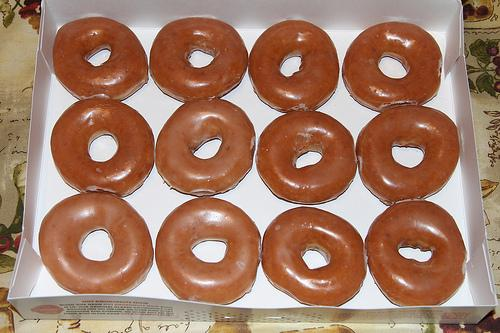How many doughnuts are in rows and covering approximately two-thirds of the box? There are eight doughnuts in two rows covering around two-thirds of the box. Are all the doughnuts in the box having the same glaze color? Yes, all the doughnuts in the box have the same white glaze color. Count the total number of doughnuts with a darker color in the image. There is one darker doughnut in the image. What is the total number of fruit and vegetable prints visible on the tablecloth? There are at least two different fruit and vegetable patterns on the tablecloth. What material is the box in the image made of? The box is made of cardboard. Describe any text or printing present on the donut box. There is writing on the side of the box, but its content is not specified in the image description. Evaluate the donut quality solely based on the visible appearance. The donuts appear to be of high quality, featuring smooth glaze and consistent coloring. Explain the visual sentiment portrayed in the image. The image conveys satisfaction and sweetness with a box of glazed doughnuts placed on a patterned tablecloth. Identify the primary object in the image and how many of it are present. There are 12 plain glazed doughnuts in the image. Describe the tablecloth in the image. The tablecloth has a pattern that includes vegetable prints and leaves. What is the main sentiment evoked by the image? Temptation or indulgence. Identify any discrepancies or abnormalities in the doughnuts in the last row. One doughnut is darker and another center is misshapen. Count the total number of glazed doughnuts in the image. 12 glazed doughnuts. Read the writing on the side of the box. Not available, the text is unspecified in the image information. Describe the attributes of the tablecloth. The tablecloth is patterned with a leaf or vegetable print. Is there any fruit on the table cloth? No, the pattern includes leaves or vegetables but not fruit. How large is the box holding the doughnuts? The box dimensions are X:25 Y:6 Width:470 Height:470. Is the doughnut at X:155 Y:196 frosted or glazed? Glazed. Analyze the interaction between the tablecloth and the doughnut box. The tablecloth provides a decorative surface for the doughnut box to rest on. How many rows are there in the box of a dozen doughnuts? Two rows. Are there only three donuts in the box located at X:27 Y:5 Width:469 Height:469? The instruction suggests that the box contains only three doughnuts, while the image contains multiple instances of boxes with various numbers of doughnuts, such as six glazed doughnuts, four brown glazed doughnuts, and a dozen glazed doughnuts. How many doughnuts are in the row with three doughnuts? Three. What kind of pattern is on the tablecloth? Leaf or vegetable pattern. What is the shape of the object at X:387 Y:198 Width:120 Height:120? It is a doughnut shape with a hole in the center. Can you see a rectangular tablecloth with a geometric pattern at X:2 Y:7 Width:55 Height:55? The instruction mentions a rectangular shape and a geometric pattern for the tablecloth, while the actual object is a tablecloth with a pattern of leaves or vegetables. Is there a small green donut box at X:25 Y:6 and Width:470 Height:470? The instruction incorrectly states the color and size of the donut box as green and small, while the actual object is a large white donut box. Describe the main object in the image. A plain glazed doughnut. What is the color of the doughnut with white glaze? Brown. Is there a blue glazed doughnut at X:50 Y:17 and Width:95 Height:95? The instruction falsely specifies the color of the doughnut as blue, while it is actually a plain glazed doughnut, which is likely brown or white. Evaluate the image quality in terms of sharpness and lighting. The image quality is good with clear sharpness and balanced lighting. Can you spot a drawing of a fish on the tablecloth located at X:468 Y:8 Width:31 Height:31? The instruction mentions a drawing of a fish on the tablecloth, but the actual object in the image is a tablecloth with a vegetable pattern or drawing of beets. Find any anomalies or unusual aspects in the image. The center of one doughnut is misshapen. Identify the object referred to as "a brown glazed donut." The doughnut at X:338 Y:7 Width:110 Height:110. Test whether the doughnuts are brown or another color. The doughnuts are brown. Do you find a doughnut without a hole in the position X:351 Y:188 Width:126 Height:126? The instruction describes a doughnut without a hole, but the actual object in the image is a doughnut with a hole in it. 